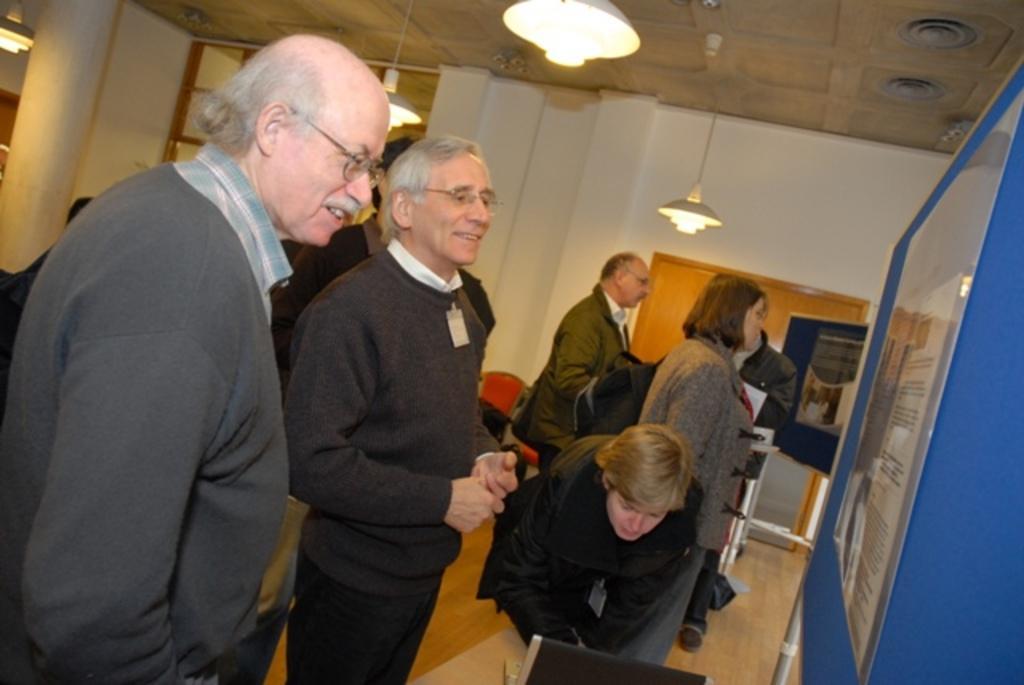Please provide a concise description of this image. In this image there are some persons standing in middle of this image , and there is a wall in the background. There are some lights arranged at top of this image and there is one notice board at right side of this image. There is one laptop at bottom of this image. 